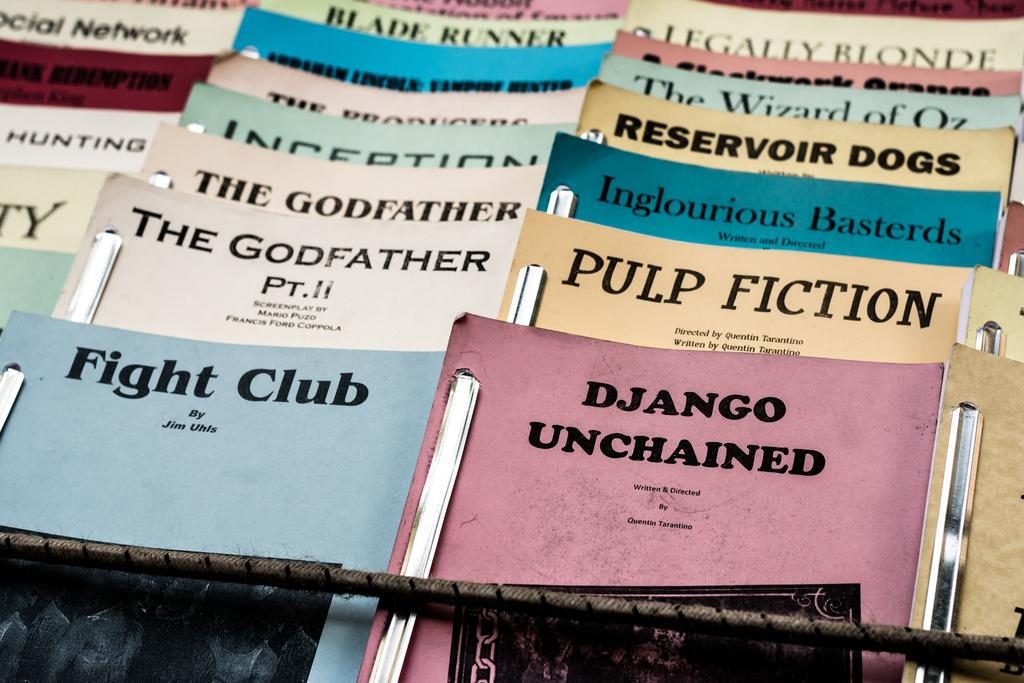<image>
Give a short and clear explanation of the subsequent image. A variety of unbound movie scripts are lined up including Fight Club. 